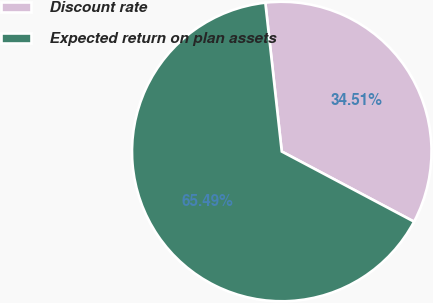Convert chart to OTSL. <chart><loc_0><loc_0><loc_500><loc_500><pie_chart><fcel>Discount rate<fcel>Expected return on plan assets<nl><fcel>34.51%<fcel>65.49%<nl></chart> 